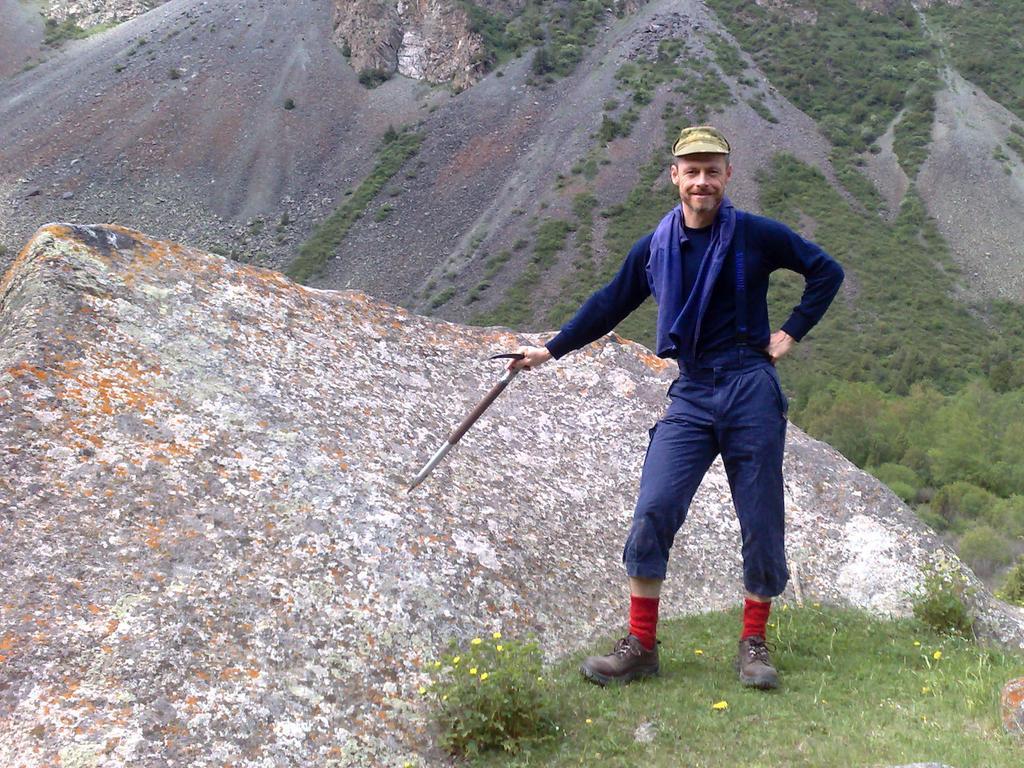How would you summarize this image in a sentence or two? In this image in front there is a person standing by holding a object. Beside him there is a rock. At the bottom of the image there is grass on the surface. In the background there are trees and we can see a sand. 